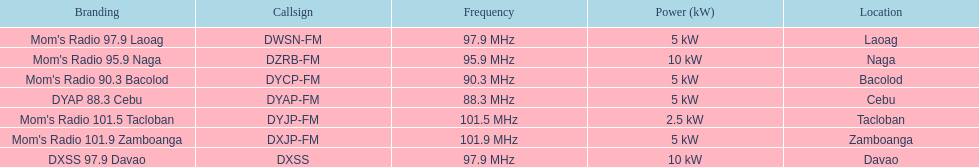What is the overall count of radio stations on this list? 7. 